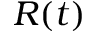<formula> <loc_0><loc_0><loc_500><loc_500>R ( t )</formula> 